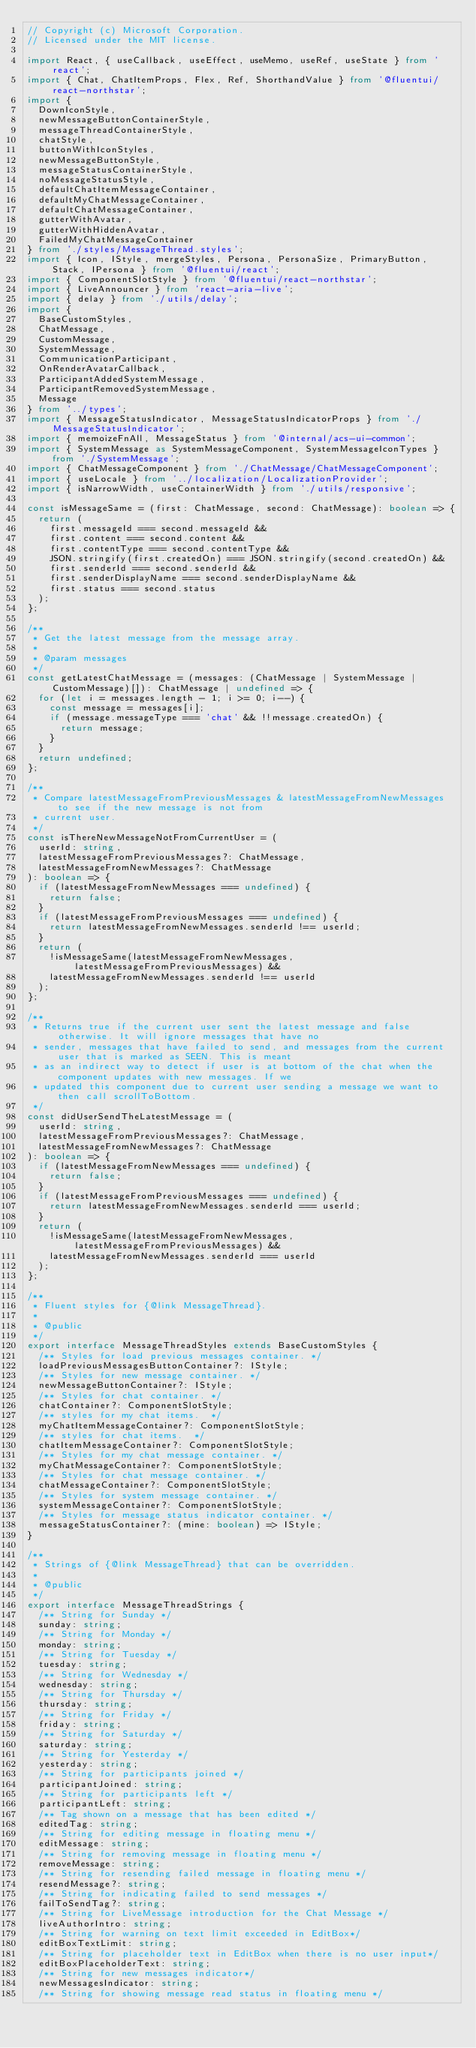<code> <loc_0><loc_0><loc_500><loc_500><_TypeScript_>// Copyright (c) Microsoft Corporation.
// Licensed under the MIT license.

import React, { useCallback, useEffect, useMemo, useRef, useState } from 'react';
import { Chat, ChatItemProps, Flex, Ref, ShorthandValue } from '@fluentui/react-northstar';
import {
  DownIconStyle,
  newMessageButtonContainerStyle,
  messageThreadContainerStyle,
  chatStyle,
  buttonWithIconStyles,
  newMessageButtonStyle,
  messageStatusContainerStyle,
  noMessageStatusStyle,
  defaultChatItemMessageContainer,
  defaultMyChatMessageContainer,
  defaultChatMessageContainer,
  gutterWithAvatar,
  gutterWithHiddenAvatar,
  FailedMyChatMessageContainer
} from './styles/MessageThread.styles';
import { Icon, IStyle, mergeStyles, Persona, PersonaSize, PrimaryButton, Stack, IPersona } from '@fluentui/react';
import { ComponentSlotStyle } from '@fluentui/react-northstar';
import { LiveAnnouncer } from 'react-aria-live';
import { delay } from './utils/delay';
import {
  BaseCustomStyles,
  ChatMessage,
  CustomMessage,
  SystemMessage,
  CommunicationParticipant,
  OnRenderAvatarCallback,
  ParticipantAddedSystemMessage,
  ParticipantRemovedSystemMessage,
  Message
} from '../types';
import { MessageStatusIndicator, MessageStatusIndicatorProps } from './MessageStatusIndicator';
import { memoizeFnAll, MessageStatus } from '@internal/acs-ui-common';
import { SystemMessage as SystemMessageComponent, SystemMessageIconTypes } from './SystemMessage';
import { ChatMessageComponent } from './ChatMessage/ChatMessageComponent';
import { useLocale } from '../localization/LocalizationProvider';
import { isNarrowWidth, useContainerWidth } from './utils/responsive';

const isMessageSame = (first: ChatMessage, second: ChatMessage): boolean => {
  return (
    first.messageId === second.messageId &&
    first.content === second.content &&
    first.contentType === second.contentType &&
    JSON.stringify(first.createdOn) === JSON.stringify(second.createdOn) &&
    first.senderId === second.senderId &&
    first.senderDisplayName === second.senderDisplayName &&
    first.status === second.status
  );
};

/**
 * Get the latest message from the message array.
 *
 * @param messages
 */
const getLatestChatMessage = (messages: (ChatMessage | SystemMessage | CustomMessage)[]): ChatMessage | undefined => {
  for (let i = messages.length - 1; i >= 0; i--) {
    const message = messages[i];
    if (message.messageType === 'chat' && !!message.createdOn) {
      return message;
    }
  }
  return undefined;
};

/**
 * Compare latestMessageFromPreviousMessages & latestMessageFromNewMessages to see if the new message is not from
 * current user.
 */
const isThereNewMessageNotFromCurrentUser = (
  userId: string,
  latestMessageFromPreviousMessages?: ChatMessage,
  latestMessageFromNewMessages?: ChatMessage
): boolean => {
  if (latestMessageFromNewMessages === undefined) {
    return false;
  }
  if (latestMessageFromPreviousMessages === undefined) {
    return latestMessageFromNewMessages.senderId !== userId;
  }
  return (
    !isMessageSame(latestMessageFromNewMessages, latestMessageFromPreviousMessages) &&
    latestMessageFromNewMessages.senderId !== userId
  );
};

/**
 * Returns true if the current user sent the latest message and false otherwise. It will ignore messages that have no
 * sender, messages that have failed to send, and messages from the current user that is marked as SEEN. This is meant
 * as an indirect way to detect if user is at bottom of the chat when the component updates with new messages. If we
 * updated this component due to current user sending a message we want to then call scrollToBottom.
 */
const didUserSendTheLatestMessage = (
  userId: string,
  latestMessageFromPreviousMessages?: ChatMessage,
  latestMessageFromNewMessages?: ChatMessage
): boolean => {
  if (latestMessageFromNewMessages === undefined) {
    return false;
  }
  if (latestMessageFromPreviousMessages === undefined) {
    return latestMessageFromNewMessages.senderId === userId;
  }
  return (
    !isMessageSame(latestMessageFromNewMessages, latestMessageFromPreviousMessages) &&
    latestMessageFromNewMessages.senderId === userId
  );
};

/**
 * Fluent styles for {@link MessageThread}.
 *
 * @public
 */
export interface MessageThreadStyles extends BaseCustomStyles {
  /** Styles for load previous messages container. */
  loadPreviousMessagesButtonContainer?: IStyle;
  /** Styles for new message container. */
  newMessageButtonContainer?: IStyle;
  /** Styles for chat container. */
  chatContainer?: ComponentSlotStyle;
  /** styles for my chat items.  */
  myChatItemMessageContainer?: ComponentSlotStyle;
  /** styles for chat items.  */
  chatItemMessageContainer?: ComponentSlotStyle;
  /** Styles for my chat message container. */
  myChatMessageContainer?: ComponentSlotStyle;
  /** Styles for chat message container. */
  chatMessageContainer?: ComponentSlotStyle;
  /** Styles for system message container. */
  systemMessageContainer?: ComponentSlotStyle;
  /** Styles for message status indicator container. */
  messageStatusContainer?: (mine: boolean) => IStyle;
}

/**
 * Strings of {@link MessageThread} that can be overridden.
 *
 * @public
 */
export interface MessageThreadStrings {
  /** String for Sunday */
  sunday: string;
  /** String for Monday */
  monday: string;
  /** String for Tuesday */
  tuesday: string;
  /** String for Wednesday */
  wednesday: string;
  /** String for Thursday */
  thursday: string;
  /** String for Friday */
  friday: string;
  /** String for Saturday */
  saturday: string;
  /** String for Yesterday */
  yesterday: string;
  /** String for participants joined */
  participantJoined: string;
  /** String for participants left */
  participantLeft: string;
  /** Tag shown on a message that has been edited */
  editedTag: string;
  /** String for editing message in floating menu */
  editMessage: string;
  /** String for removing message in floating menu */
  removeMessage: string;
  /** String for resending failed message in floating menu */
  resendMessage?: string;
  /** String for indicating failed to send messages */
  failToSendTag?: string;
  /** String for LiveMessage introduction for the Chat Message */
  liveAuthorIntro: string;
  /** String for warning on text limit exceeded in EditBox*/
  editBoxTextLimit: string;
  /** String for placeholder text in EditBox when there is no user input*/
  editBoxPlaceholderText: string;
  /** String for new messages indicator*/
  newMessagesIndicator: string;
  /** String for showing message read status in floating menu */</code> 